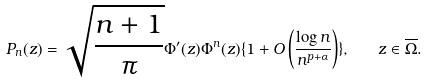<formula> <loc_0><loc_0><loc_500><loc_500>P _ { n } ( z ) = \sqrt { \frac { n + 1 } { \pi } } \Phi ^ { \prime } ( z ) \Phi ^ { n } ( z ) \{ 1 + O \left ( \frac { \log n } { n ^ { p + \alpha } } \right ) \} , \quad z \in \overline { \Omega } .</formula> 